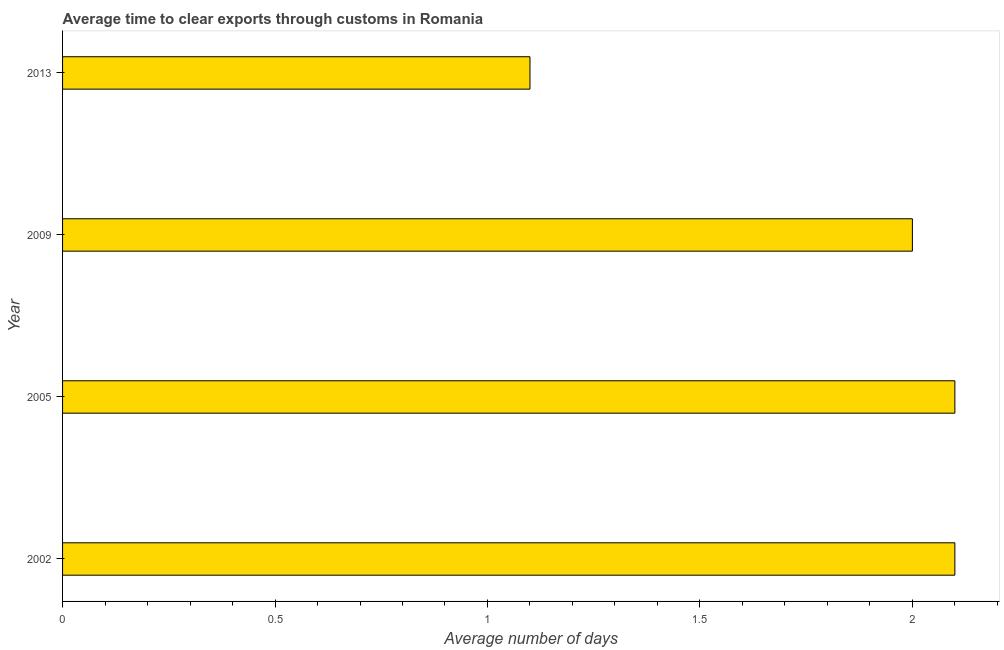Does the graph contain any zero values?
Provide a short and direct response. No. What is the title of the graph?
Your answer should be compact. Average time to clear exports through customs in Romania. What is the label or title of the X-axis?
Offer a terse response. Average number of days. What is the label or title of the Y-axis?
Your answer should be very brief. Year. Across all years, what is the minimum time to clear exports through customs?
Give a very brief answer. 1.1. What is the sum of the time to clear exports through customs?
Provide a succinct answer. 7.3. What is the average time to clear exports through customs per year?
Ensure brevity in your answer.  1.82. What is the median time to clear exports through customs?
Your answer should be compact. 2.05. In how many years, is the time to clear exports through customs greater than 1.5 days?
Give a very brief answer. 3. Do a majority of the years between 2013 and 2005 (inclusive) have time to clear exports through customs greater than 0.9 days?
Provide a succinct answer. Yes. Is the time to clear exports through customs in 2005 less than that in 2009?
Ensure brevity in your answer.  No. Is the difference between the time to clear exports through customs in 2005 and 2013 greater than the difference between any two years?
Keep it short and to the point. Yes. What is the difference between the highest and the second highest time to clear exports through customs?
Give a very brief answer. 0. Is the sum of the time to clear exports through customs in 2005 and 2013 greater than the maximum time to clear exports through customs across all years?
Your answer should be compact. Yes. What is the difference between the highest and the lowest time to clear exports through customs?
Your answer should be very brief. 1. Are all the bars in the graph horizontal?
Make the answer very short. Yes. Are the values on the major ticks of X-axis written in scientific E-notation?
Make the answer very short. No. What is the Average number of days of 2002?
Make the answer very short. 2.1. What is the Average number of days of 2005?
Offer a very short reply. 2.1. What is the difference between the Average number of days in 2002 and 2009?
Provide a short and direct response. 0.1. What is the difference between the Average number of days in 2002 and 2013?
Provide a short and direct response. 1. What is the difference between the Average number of days in 2005 and 2009?
Make the answer very short. 0.1. What is the difference between the Average number of days in 2005 and 2013?
Provide a succinct answer. 1. What is the ratio of the Average number of days in 2002 to that in 2005?
Keep it short and to the point. 1. What is the ratio of the Average number of days in 2002 to that in 2009?
Provide a short and direct response. 1.05. What is the ratio of the Average number of days in 2002 to that in 2013?
Your answer should be very brief. 1.91. What is the ratio of the Average number of days in 2005 to that in 2009?
Your response must be concise. 1.05. What is the ratio of the Average number of days in 2005 to that in 2013?
Your answer should be compact. 1.91. What is the ratio of the Average number of days in 2009 to that in 2013?
Give a very brief answer. 1.82. 